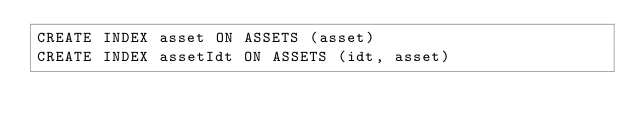Convert code to text. <code><loc_0><loc_0><loc_500><loc_500><_SQL_>CREATE INDEX asset ON ASSETS (asset)
CREATE INDEX assetIdt ON ASSETS (idt, asset)</code> 